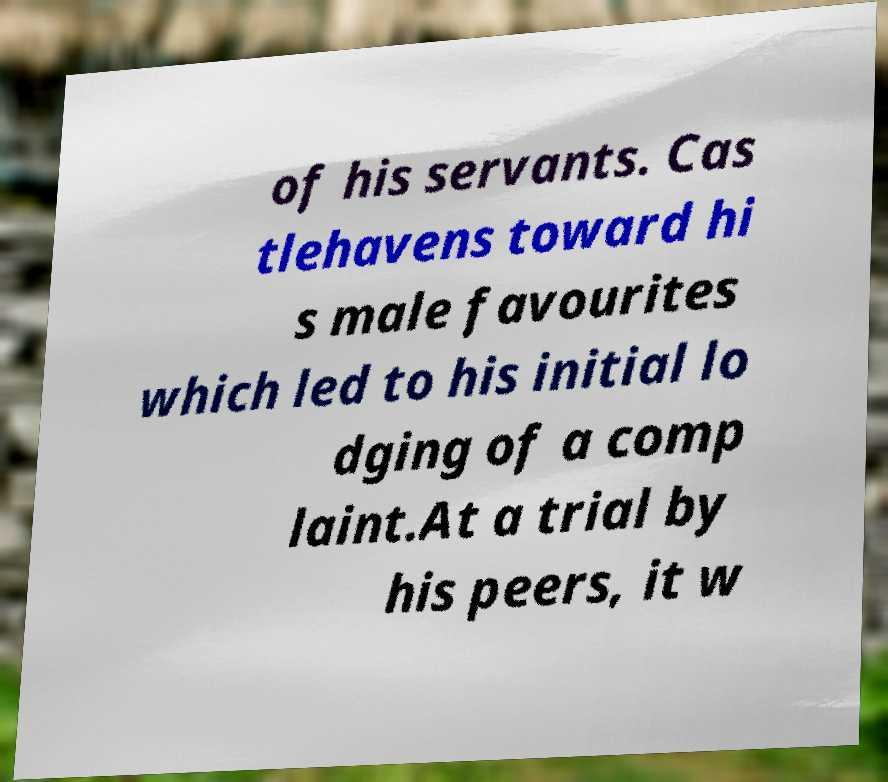Please identify and transcribe the text found in this image. of his servants. Cas tlehavens toward hi s male favourites which led to his initial lo dging of a comp laint.At a trial by his peers, it w 